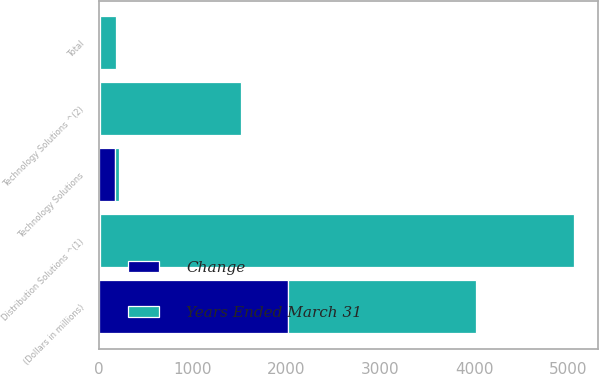Convert chart. <chart><loc_0><loc_0><loc_500><loc_500><stacked_bar_chart><ecel><fcel>(Dollars in millions)<fcel>Distribution Solutions ^(1)<fcel>Technology Solutions ^(2)<fcel>Total<fcel>Technology Solutions<nl><fcel>Years Ended March 31<fcel>2012<fcel>5057<fcel>1510<fcel>165<fcel>45.62<nl><fcel>Change<fcel>2012<fcel>11<fcel>7<fcel>10<fcel>165<nl></chart> 